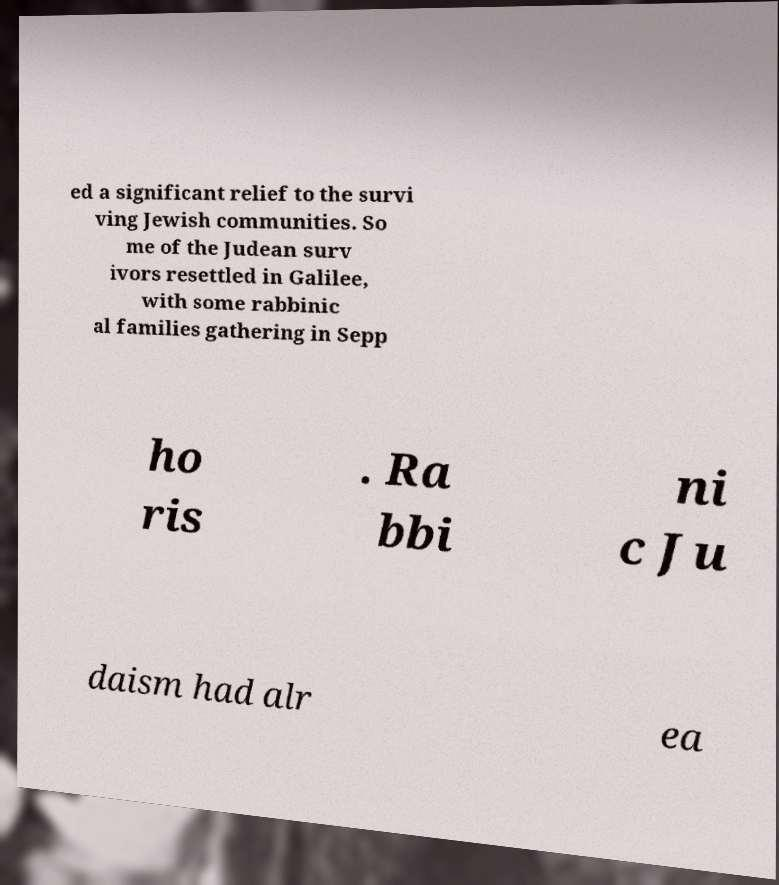What messages or text are displayed in this image? I need them in a readable, typed format. ed a significant relief to the survi ving Jewish communities. So me of the Judean surv ivors resettled in Galilee, with some rabbinic al families gathering in Sepp ho ris . Ra bbi ni c Ju daism had alr ea 